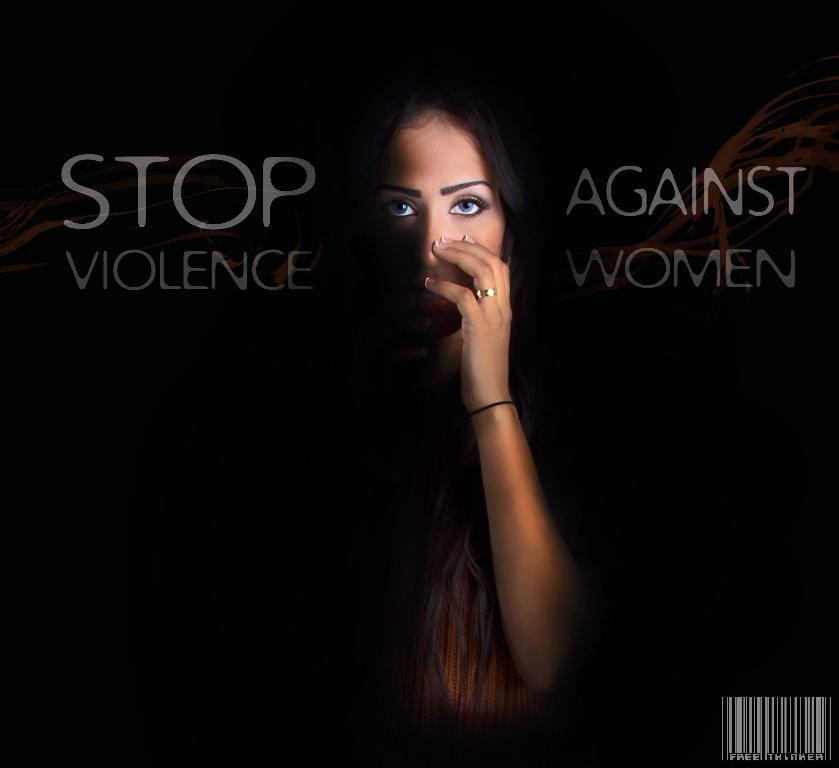What is the main subject in the center of the image? There is a poster in the center of the image. What is depicted on the poster? The poster features a woman. Are there any words or letters on the poster? Yes, there is text on the poster. How many seeds can be seen on the woman's finger in the image? There are no seeds or fingers visible in the image; the poster only features a woman and text. 